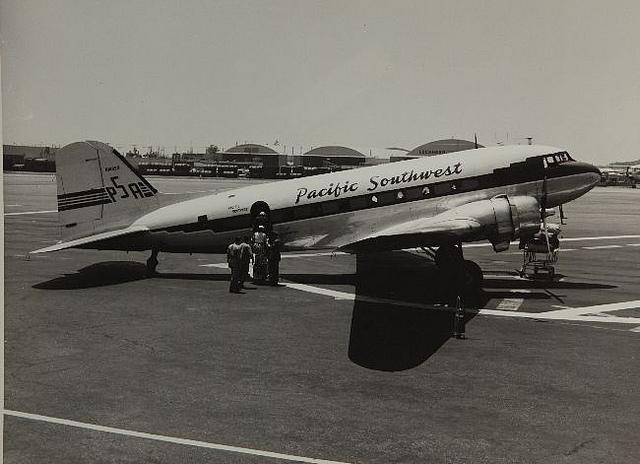How many shadows can you count?
Give a very brief answer. 1. 